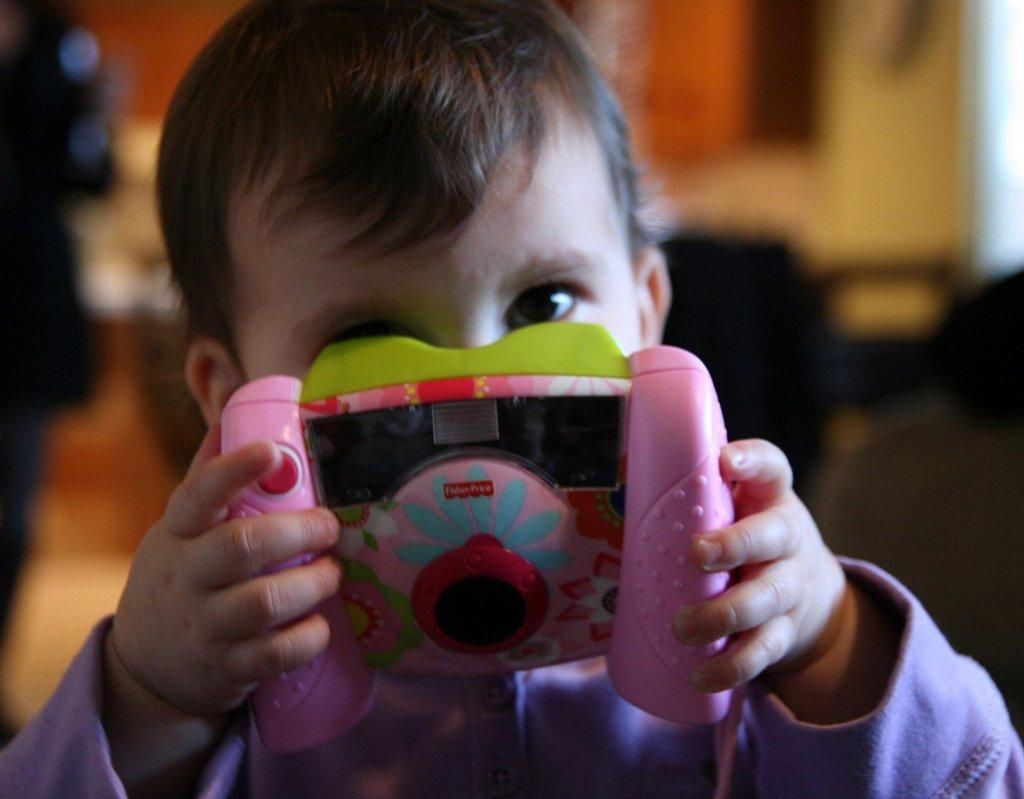What is the main subject of the image? The main subject of the image is a kid. What is the kid holding in their hands? The kid is holding a toy in their hands. What degree does the carpenter have in the image? There is no carpenter or degree present in the image. 